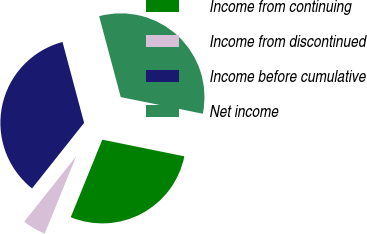Convert chart to OTSL. <chart><loc_0><loc_0><loc_500><loc_500><pie_chart><fcel>Income from continuing<fcel>Income from discontinued<fcel>Income before cumulative<fcel>Net income<nl><fcel>27.97%<fcel>4.52%<fcel>35.17%<fcel>32.34%<nl></chart> 